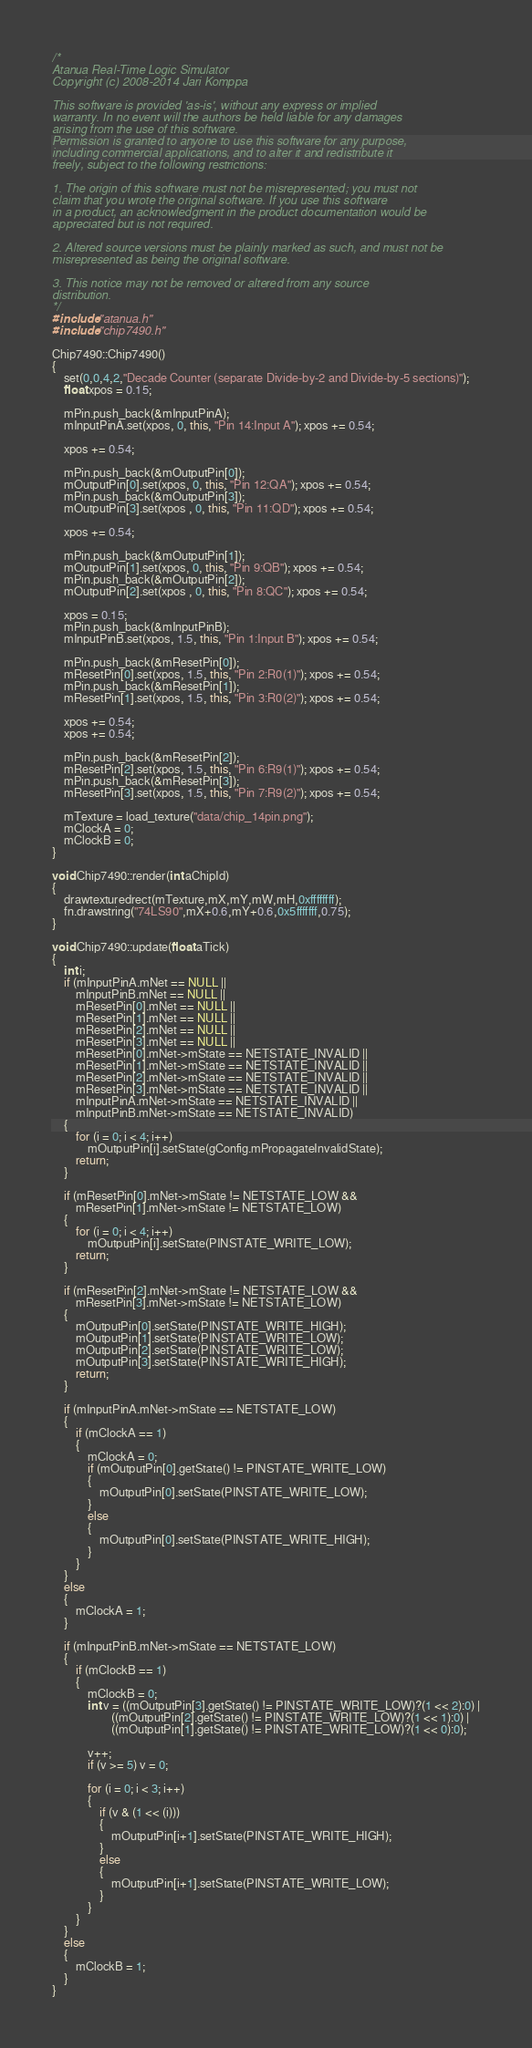Convert code to text. <code><loc_0><loc_0><loc_500><loc_500><_C++_>/*
Atanua Real-Time Logic Simulator
Copyright (c) 2008-2014 Jari Komppa

This software is provided 'as-is', without any express or implied
warranty. In no event will the authors be held liable for any damages
arising from the use of this software.
Permission is granted to anyone to use this software for any purpose,
including commercial applications, and to alter it and redistribute it
freely, subject to the following restrictions:

1. The origin of this software must not be misrepresented; you must not
claim that you wrote the original software. If you use this software
in a product, an acknowledgment in the product documentation would be
appreciated but is not required.

2. Altered source versions must be plainly marked as such, and must not be
misrepresented as being the original software.

3. This notice may not be removed or altered from any source
distribution.
*/
#include "atanua.h"
#include "chip7490.h"

Chip7490::Chip7490()
{
    set(0,0,4,2,"Decade Counter (separate Divide-by-2 and Divide-by-5 sections)");
    float xpos = 0.15;
    
    mPin.push_back(&mInputPinA);
    mInputPinA.set(xpos, 0, this, "Pin 14:Input A"); xpos += 0.54;
    
    xpos += 0.54;
    
    mPin.push_back(&mOutputPin[0]);
    mOutputPin[0].set(xpos, 0, this, "Pin 12:QA"); xpos += 0.54;
    mPin.push_back(&mOutputPin[3]);
    mOutputPin[3].set(xpos , 0, this, "Pin 11:QD"); xpos += 0.54;

    xpos += 0.54;

    mPin.push_back(&mOutputPin[1]);
    mOutputPin[1].set(xpos, 0, this, "Pin 9:QB"); xpos += 0.54;
    mPin.push_back(&mOutputPin[2]);
    mOutputPin[2].set(xpos , 0, this, "Pin 8:QC"); xpos += 0.54;

    xpos = 0.15;
    mPin.push_back(&mInputPinB);
    mInputPinB.set(xpos, 1.5, this, "Pin 1:Input B"); xpos += 0.54;

    mPin.push_back(&mResetPin[0]);
    mResetPin[0].set(xpos, 1.5, this, "Pin 2:R0(1)"); xpos += 0.54;
    mPin.push_back(&mResetPin[1]);
    mResetPin[1].set(xpos, 1.5, this, "Pin 3:R0(2)"); xpos += 0.54;
    
    xpos += 0.54;
    xpos += 0.54;

    mPin.push_back(&mResetPin[2]);
    mResetPin[2].set(xpos, 1.5, this, "Pin 6:R9(1)"); xpos += 0.54;
    mPin.push_back(&mResetPin[3]);
    mResetPin[3].set(xpos, 1.5, this, "Pin 7:R9(2)"); xpos += 0.54;

    mTexture = load_texture("data/chip_14pin.png");
    mClockA = 0;
    mClockB = 0;
}

void Chip7490::render(int aChipId)
{
    drawtexturedrect(mTexture,mX,mY,mW,mH,0xffffffff);
    fn.drawstring("74LS90",mX+0.6,mY+0.6,0x5fffffff,0.75);
}

void Chip7490::update(float aTick) 
{
    int i;
    if (mInputPinA.mNet == NULL ||
        mInputPinB.mNet == NULL ||
        mResetPin[0].mNet == NULL ||
        mResetPin[1].mNet == NULL ||
        mResetPin[2].mNet == NULL ||
        mResetPin[3].mNet == NULL ||
        mResetPin[0].mNet->mState == NETSTATE_INVALID ||
        mResetPin[1].mNet->mState == NETSTATE_INVALID ||
        mResetPin[2].mNet->mState == NETSTATE_INVALID ||
        mResetPin[3].mNet->mState == NETSTATE_INVALID ||
        mInputPinA.mNet->mState == NETSTATE_INVALID ||
        mInputPinB.mNet->mState == NETSTATE_INVALID)
    {
        for (i = 0; i < 4; i++)
            mOutputPin[i].setState(gConfig.mPropagateInvalidState);
        return;
    }

    if (mResetPin[0].mNet->mState != NETSTATE_LOW &&
        mResetPin[1].mNet->mState != NETSTATE_LOW)
    {
        for (i = 0; i < 4; i++)
            mOutputPin[i].setState(PINSTATE_WRITE_LOW);
        return;
    }

    if (mResetPin[2].mNet->mState != NETSTATE_LOW &&
        mResetPin[3].mNet->mState != NETSTATE_LOW)
    {
        mOutputPin[0].setState(PINSTATE_WRITE_HIGH);
        mOutputPin[1].setState(PINSTATE_WRITE_LOW);
        mOutputPin[2].setState(PINSTATE_WRITE_LOW);
        mOutputPin[3].setState(PINSTATE_WRITE_HIGH);
        return;
    }

    if (mInputPinA.mNet->mState == NETSTATE_LOW)
    {
        if (mClockA == 1)
        {
            mClockA = 0;
            if (mOutputPin[0].getState() != PINSTATE_WRITE_LOW)
            {
                mOutputPin[0].setState(PINSTATE_WRITE_LOW);
            }
            else
            {
                mOutputPin[0].setState(PINSTATE_WRITE_HIGH);
            }
        }
    }
    else
    {
        mClockA = 1;
    }

    if (mInputPinB.mNet->mState == NETSTATE_LOW)
    {
        if (mClockB == 1)
        {
            mClockB = 0;
            int v = ((mOutputPin[3].getState() != PINSTATE_WRITE_LOW)?(1 << 2):0) |
                    ((mOutputPin[2].getState() != PINSTATE_WRITE_LOW)?(1 << 1):0) |
                    ((mOutputPin[1].getState() != PINSTATE_WRITE_LOW)?(1 << 0):0);

            v++;
            if (v >= 5) v = 0;

            for (i = 0; i < 3; i++)
            {
                if (v & (1 << (i)))
                {
                    mOutputPin[i+1].setState(PINSTATE_WRITE_HIGH);
                }
                else
                {
                    mOutputPin[i+1].setState(PINSTATE_WRITE_LOW);
                }
            }
        }
    }
    else
    {
        mClockB = 1;
    }
}    
</code> 